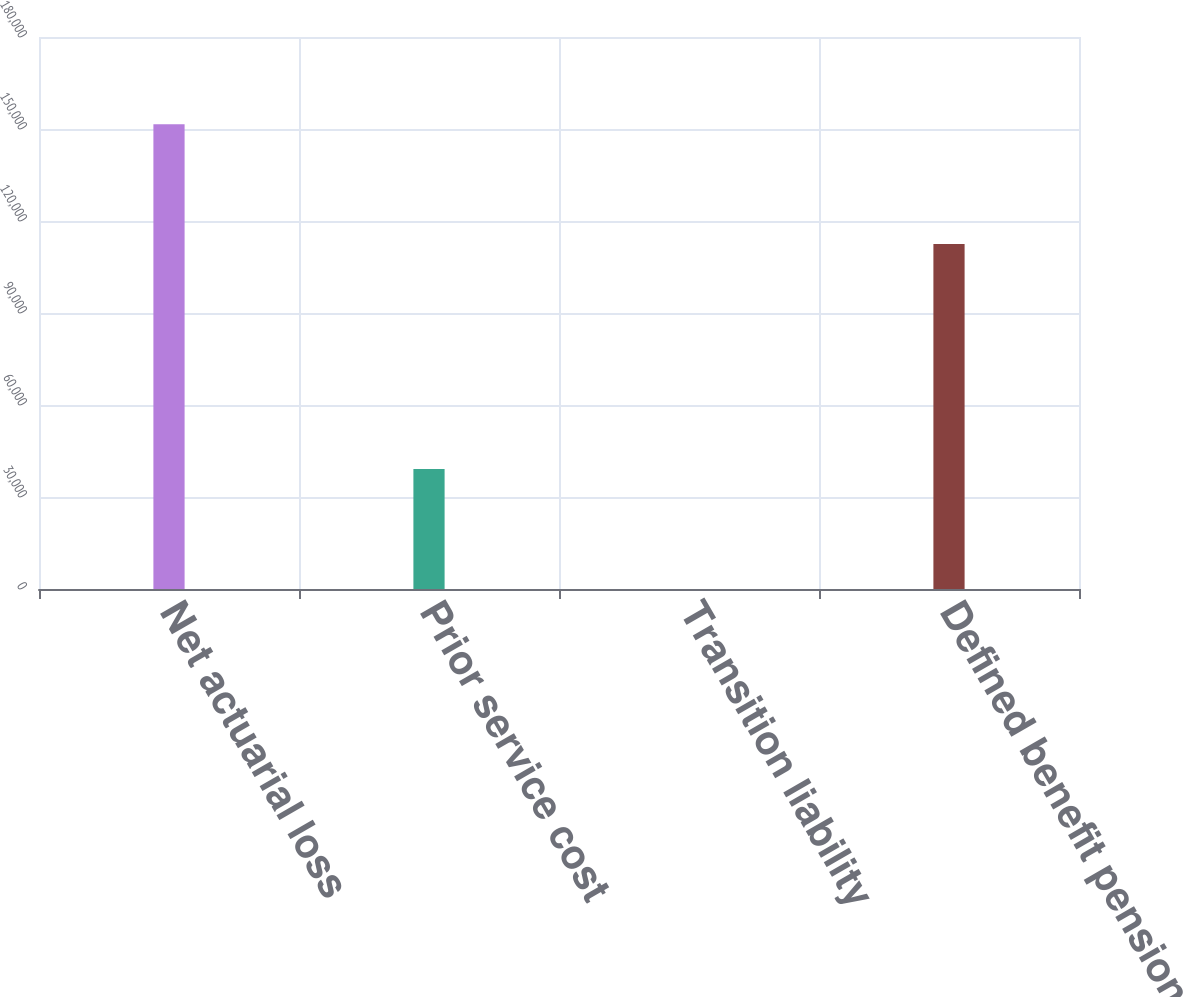Convert chart. <chart><loc_0><loc_0><loc_500><loc_500><bar_chart><fcel>Net actuarial loss<fcel>Prior service cost<fcel>Transition liability<fcel>Defined benefit pension plans<nl><fcel>151564<fcel>39093<fcel>3<fcel>112468<nl></chart> 